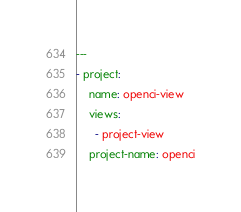Convert code to text. <code><loc_0><loc_0><loc_500><loc_500><_YAML_>---
- project:
    name: openci-view
    views:
      - project-view
    project-name: openci
</code> 